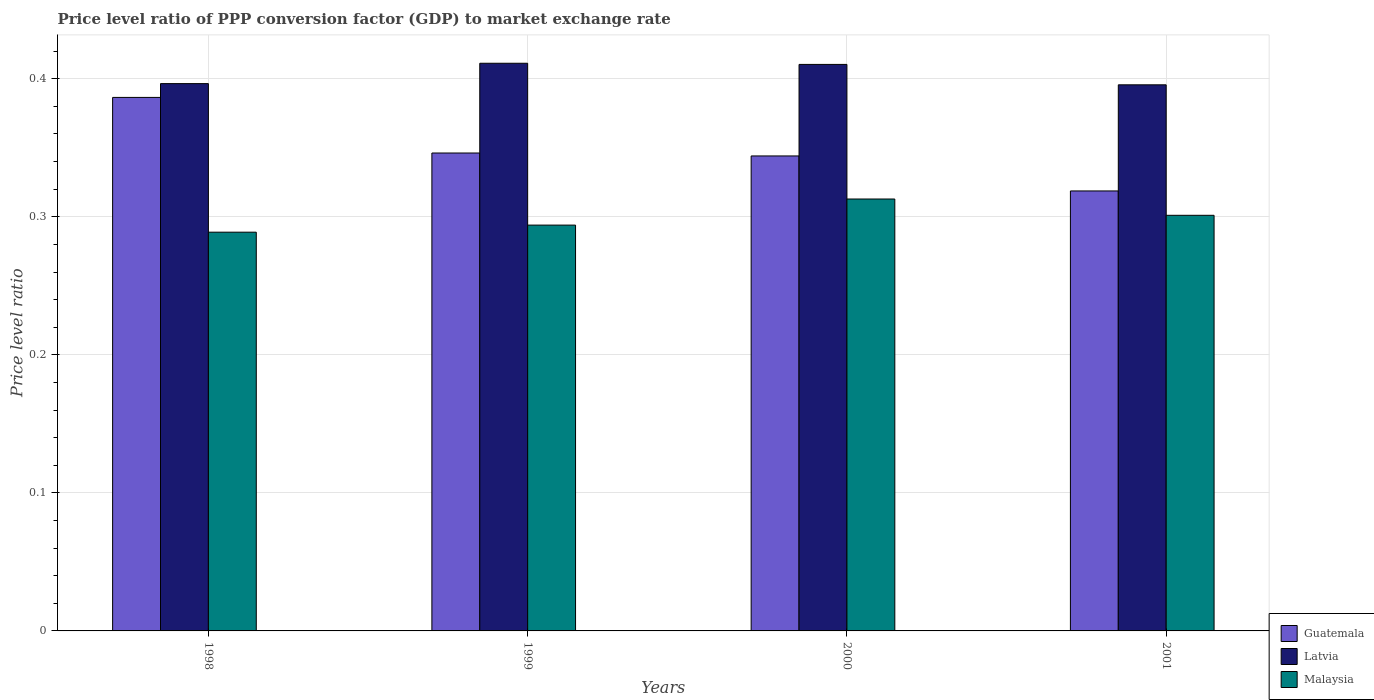How many different coloured bars are there?
Your answer should be very brief. 3. How many groups of bars are there?
Your answer should be very brief. 4. Are the number of bars on each tick of the X-axis equal?
Offer a very short reply. Yes. How many bars are there on the 4th tick from the left?
Ensure brevity in your answer.  3. How many bars are there on the 3rd tick from the right?
Offer a very short reply. 3. What is the price level ratio in Latvia in 2000?
Offer a very short reply. 0.41. Across all years, what is the maximum price level ratio in Guatemala?
Your answer should be compact. 0.39. Across all years, what is the minimum price level ratio in Guatemala?
Your response must be concise. 0.32. In which year was the price level ratio in Guatemala maximum?
Your answer should be very brief. 1998. In which year was the price level ratio in Latvia minimum?
Provide a succinct answer. 2001. What is the total price level ratio in Guatemala in the graph?
Keep it short and to the point. 1.4. What is the difference between the price level ratio in Malaysia in 1998 and that in 2000?
Provide a succinct answer. -0.02. What is the difference between the price level ratio in Guatemala in 2001 and the price level ratio in Malaysia in 1999?
Keep it short and to the point. 0.02. What is the average price level ratio in Guatemala per year?
Ensure brevity in your answer.  0.35. In the year 2001, what is the difference between the price level ratio in Latvia and price level ratio in Guatemala?
Give a very brief answer. 0.08. What is the ratio of the price level ratio in Guatemala in 1999 to that in 2000?
Your response must be concise. 1.01. Is the difference between the price level ratio in Latvia in 1999 and 2000 greater than the difference between the price level ratio in Guatemala in 1999 and 2000?
Give a very brief answer. No. What is the difference between the highest and the second highest price level ratio in Malaysia?
Your response must be concise. 0.01. What is the difference between the highest and the lowest price level ratio in Latvia?
Provide a succinct answer. 0.02. What does the 3rd bar from the left in 2001 represents?
Offer a very short reply. Malaysia. What does the 1st bar from the right in 1998 represents?
Your answer should be very brief. Malaysia. Is it the case that in every year, the sum of the price level ratio in Malaysia and price level ratio in Guatemala is greater than the price level ratio in Latvia?
Give a very brief answer. Yes. How many bars are there?
Ensure brevity in your answer.  12. Are all the bars in the graph horizontal?
Give a very brief answer. No. How many years are there in the graph?
Ensure brevity in your answer.  4. Are the values on the major ticks of Y-axis written in scientific E-notation?
Give a very brief answer. No. Does the graph contain any zero values?
Ensure brevity in your answer.  No. What is the title of the graph?
Give a very brief answer. Price level ratio of PPP conversion factor (GDP) to market exchange rate. Does "Sierra Leone" appear as one of the legend labels in the graph?
Ensure brevity in your answer.  No. What is the label or title of the X-axis?
Your answer should be compact. Years. What is the label or title of the Y-axis?
Give a very brief answer. Price level ratio. What is the Price level ratio of Guatemala in 1998?
Keep it short and to the point. 0.39. What is the Price level ratio in Latvia in 1998?
Provide a succinct answer. 0.4. What is the Price level ratio in Malaysia in 1998?
Keep it short and to the point. 0.29. What is the Price level ratio of Guatemala in 1999?
Your answer should be very brief. 0.35. What is the Price level ratio of Latvia in 1999?
Give a very brief answer. 0.41. What is the Price level ratio of Malaysia in 1999?
Your response must be concise. 0.29. What is the Price level ratio of Guatemala in 2000?
Offer a terse response. 0.34. What is the Price level ratio of Latvia in 2000?
Give a very brief answer. 0.41. What is the Price level ratio of Malaysia in 2000?
Ensure brevity in your answer.  0.31. What is the Price level ratio of Guatemala in 2001?
Offer a terse response. 0.32. What is the Price level ratio of Latvia in 2001?
Your response must be concise. 0.4. What is the Price level ratio of Malaysia in 2001?
Make the answer very short. 0.3. Across all years, what is the maximum Price level ratio of Guatemala?
Give a very brief answer. 0.39. Across all years, what is the maximum Price level ratio of Latvia?
Make the answer very short. 0.41. Across all years, what is the maximum Price level ratio in Malaysia?
Your response must be concise. 0.31. Across all years, what is the minimum Price level ratio in Guatemala?
Give a very brief answer. 0.32. Across all years, what is the minimum Price level ratio in Latvia?
Ensure brevity in your answer.  0.4. Across all years, what is the minimum Price level ratio in Malaysia?
Keep it short and to the point. 0.29. What is the total Price level ratio in Guatemala in the graph?
Ensure brevity in your answer.  1.4. What is the total Price level ratio in Latvia in the graph?
Ensure brevity in your answer.  1.61. What is the total Price level ratio of Malaysia in the graph?
Offer a very short reply. 1.2. What is the difference between the Price level ratio in Guatemala in 1998 and that in 1999?
Your response must be concise. 0.04. What is the difference between the Price level ratio in Latvia in 1998 and that in 1999?
Keep it short and to the point. -0.01. What is the difference between the Price level ratio in Malaysia in 1998 and that in 1999?
Your answer should be very brief. -0.01. What is the difference between the Price level ratio of Guatemala in 1998 and that in 2000?
Offer a very short reply. 0.04. What is the difference between the Price level ratio of Latvia in 1998 and that in 2000?
Your answer should be compact. -0.01. What is the difference between the Price level ratio in Malaysia in 1998 and that in 2000?
Make the answer very short. -0.02. What is the difference between the Price level ratio of Guatemala in 1998 and that in 2001?
Keep it short and to the point. 0.07. What is the difference between the Price level ratio of Latvia in 1998 and that in 2001?
Give a very brief answer. 0. What is the difference between the Price level ratio in Malaysia in 1998 and that in 2001?
Make the answer very short. -0.01. What is the difference between the Price level ratio of Guatemala in 1999 and that in 2000?
Ensure brevity in your answer.  0. What is the difference between the Price level ratio in Latvia in 1999 and that in 2000?
Your answer should be very brief. 0. What is the difference between the Price level ratio of Malaysia in 1999 and that in 2000?
Ensure brevity in your answer.  -0.02. What is the difference between the Price level ratio of Guatemala in 1999 and that in 2001?
Provide a short and direct response. 0.03. What is the difference between the Price level ratio in Latvia in 1999 and that in 2001?
Provide a short and direct response. 0.02. What is the difference between the Price level ratio of Malaysia in 1999 and that in 2001?
Make the answer very short. -0.01. What is the difference between the Price level ratio of Guatemala in 2000 and that in 2001?
Give a very brief answer. 0.03. What is the difference between the Price level ratio in Latvia in 2000 and that in 2001?
Your answer should be compact. 0.01. What is the difference between the Price level ratio of Malaysia in 2000 and that in 2001?
Ensure brevity in your answer.  0.01. What is the difference between the Price level ratio in Guatemala in 1998 and the Price level ratio in Latvia in 1999?
Your response must be concise. -0.02. What is the difference between the Price level ratio in Guatemala in 1998 and the Price level ratio in Malaysia in 1999?
Keep it short and to the point. 0.09. What is the difference between the Price level ratio of Latvia in 1998 and the Price level ratio of Malaysia in 1999?
Make the answer very short. 0.1. What is the difference between the Price level ratio of Guatemala in 1998 and the Price level ratio of Latvia in 2000?
Make the answer very short. -0.02. What is the difference between the Price level ratio of Guatemala in 1998 and the Price level ratio of Malaysia in 2000?
Offer a terse response. 0.07. What is the difference between the Price level ratio in Latvia in 1998 and the Price level ratio in Malaysia in 2000?
Offer a very short reply. 0.08. What is the difference between the Price level ratio in Guatemala in 1998 and the Price level ratio in Latvia in 2001?
Your answer should be very brief. -0.01. What is the difference between the Price level ratio in Guatemala in 1998 and the Price level ratio in Malaysia in 2001?
Your answer should be very brief. 0.09. What is the difference between the Price level ratio in Latvia in 1998 and the Price level ratio in Malaysia in 2001?
Make the answer very short. 0.1. What is the difference between the Price level ratio in Guatemala in 1999 and the Price level ratio in Latvia in 2000?
Your response must be concise. -0.06. What is the difference between the Price level ratio in Guatemala in 1999 and the Price level ratio in Malaysia in 2000?
Provide a succinct answer. 0.03. What is the difference between the Price level ratio of Latvia in 1999 and the Price level ratio of Malaysia in 2000?
Your answer should be very brief. 0.1. What is the difference between the Price level ratio of Guatemala in 1999 and the Price level ratio of Latvia in 2001?
Make the answer very short. -0.05. What is the difference between the Price level ratio in Guatemala in 1999 and the Price level ratio in Malaysia in 2001?
Make the answer very short. 0.05. What is the difference between the Price level ratio in Latvia in 1999 and the Price level ratio in Malaysia in 2001?
Keep it short and to the point. 0.11. What is the difference between the Price level ratio in Guatemala in 2000 and the Price level ratio in Latvia in 2001?
Offer a very short reply. -0.05. What is the difference between the Price level ratio of Guatemala in 2000 and the Price level ratio of Malaysia in 2001?
Ensure brevity in your answer.  0.04. What is the difference between the Price level ratio in Latvia in 2000 and the Price level ratio in Malaysia in 2001?
Offer a very short reply. 0.11. What is the average Price level ratio in Guatemala per year?
Offer a very short reply. 0.35. What is the average Price level ratio of Latvia per year?
Offer a terse response. 0.4. What is the average Price level ratio of Malaysia per year?
Offer a terse response. 0.3. In the year 1998, what is the difference between the Price level ratio in Guatemala and Price level ratio in Latvia?
Give a very brief answer. -0.01. In the year 1998, what is the difference between the Price level ratio in Guatemala and Price level ratio in Malaysia?
Ensure brevity in your answer.  0.1. In the year 1998, what is the difference between the Price level ratio of Latvia and Price level ratio of Malaysia?
Your answer should be very brief. 0.11. In the year 1999, what is the difference between the Price level ratio in Guatemala and Price level ratio in Latvia?
Your answer should be compact. -0.07. In the year 1999, what is the difference between the Price level ratio in Guatemala and Price level ratio in Malaysia?
Your answer should be very brief. 0.05. In the year 1999, what is the difference between the Price level ratio in Latvia and Price level ratio in Malaysia?
Ensure brevity in your answer.  0.12. In the year 2000, what is the difference between the Price level ratio of Guatemala and Price level ratio of Latvia?
Your answer should be very brief. -0.07. In the year 2000, what is the difference between the Price level ratio in Guatemala and Price level ratio in Malaysia?
Offer a very short reply. 0.03. In the year 2000, what is the difference between the Price level ratio of Latvia and Price level ratio of Malaysia?
Give a very brief answer. 0.1. In the year 2001, what is the difference between the Price level ratio in Guatemala and Price level ratio in Latvia?
Your answer should be very brief. -0.08. In the year 2001, what is the difference between the Price level ratio of Guatemala and Price level ratio of Malaysia?
Your response must be concise. 0.02. In the year 2001, what is the difference between the Price level ratio in Latvia and Price level ratio in Malaysia?
Ensure brevity in your answer.  0.09. What is the ratio of the Price level ratio in Guatemala in 1998 to that in 1999?
Your answer should be compact. 1.12. What is the ratio of the Price level ratio of Latvia in 1998 to that in 1999?
Your answer should be very brief. 0.96. What is the ratio of the Price level ratio in Malaysia in 1998 to that in 1999?
Your answer should be very brief. 0.98. What is the ratio of the Price level ratio in Guatemala in 1998 to that in 2000?
Offer a terse response. 1.12. What is the ratio of the Price level ratio of Latvia in 1998 to that in 2000?
Make the answer very short. 0.97. What is the ratio of the Price level ratio of Malaysia in 1998 to that in 2000?
Offer a very short reply. 0.92. What is the ratio of the Price level ratio of Guatemala in 1998 to that in 2001?
Offer a very short reply. 1.21. What is the ratio of the Price level ratio in Latvia in 1998 to that in 2001?
Your answer should be compact. 1. What is the ratio of the Price level ratio in Malaysia in 1998 to that in 2001?
Your response must be concise. 0.96. What is the ratio of the Price level ratio in Guatemala in 1999 to that in 2000?
Your answer should be very brief. 1.01. What is the ratio of the Price level ratio of Malaysia in 1999 to that in 2000?
Provide a short and direct response. 0.94. What is the ratio of the Price level ratio in Guatemala in 1999 to that in 2001?
Make the answer very short. 1.09. What is the ratio of the Price level ratio of Latvia in 1999 to that in 2001?
Offer a very short reply. 1.04. What is the ratio of the Price level ratio in Malaysia in 1999 to that in 2001?
Provide a succinct answer. 0.98. What is the ratio of the Price level ratio of Guatemala in 2000 to that in 2001?
Give a very brief answer. 1.08. What is the ratio of the Price level ratio in Latvia in 2000 to that in 2001?
Keep it short and to the point. 1.04. What is the ratio of the Price level ratio in Malaysia in 2000 to that in 2001?
Offer a terse response. 1.04. What is the difference between the highest and the second highest Price level ratio in Guatemala?
Ensure brevity in your answer.  0.04. What is the difference between the highest and the second highest Price level ratio of Latvia?
Provide a succinct answer. 0. What is the difference between the highest and the second highest Price level ratio of Malaysia?
Your response must be concise. 0.01. What is the difference between the highest and the lowest Price level ratio in Guatemala?
Keep it short and to the point. 0.07. What is the difference between the highest and the lowest Price level ratio of Latvia?
Your answer should be compact. 0.02. What is the difference between the highest and the lowest Price level ratio of Malaysia?
Offer a terse response. 0.02. 